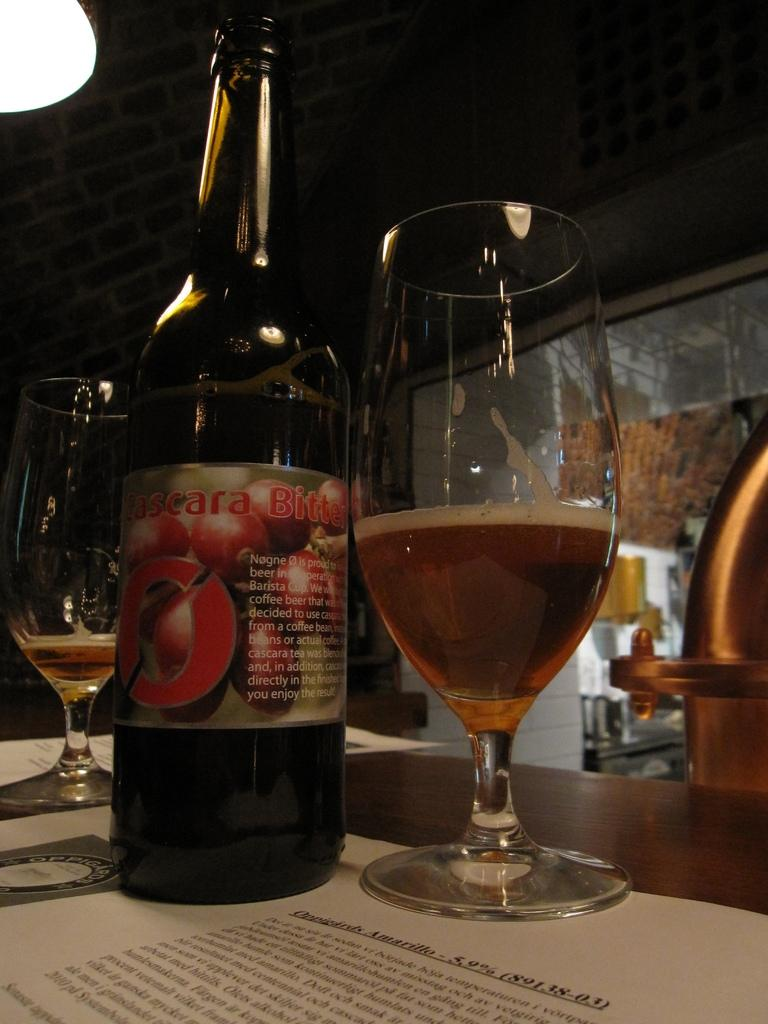What is present on the table in the image? There is a bottle and a glass with a drink on the table in the image. What is the purpose of the bottle and glass? The bottle and glass are likely used for holding and consuming a beverage. What else can be seen in the image besides the bottle and glass? There is a paper and a glass door in the background of the image. Can you describe the glass door in the background? The glass door is a transparent door made of glass, and it is visible in the background of the image. In which direction is the wrench pointing in the image? There is no wrench present in the image. How is the concept of division represented in the image? The concept of division is not represented in the image, as it contains a bottle, a glass, a paper, and a glass door. 